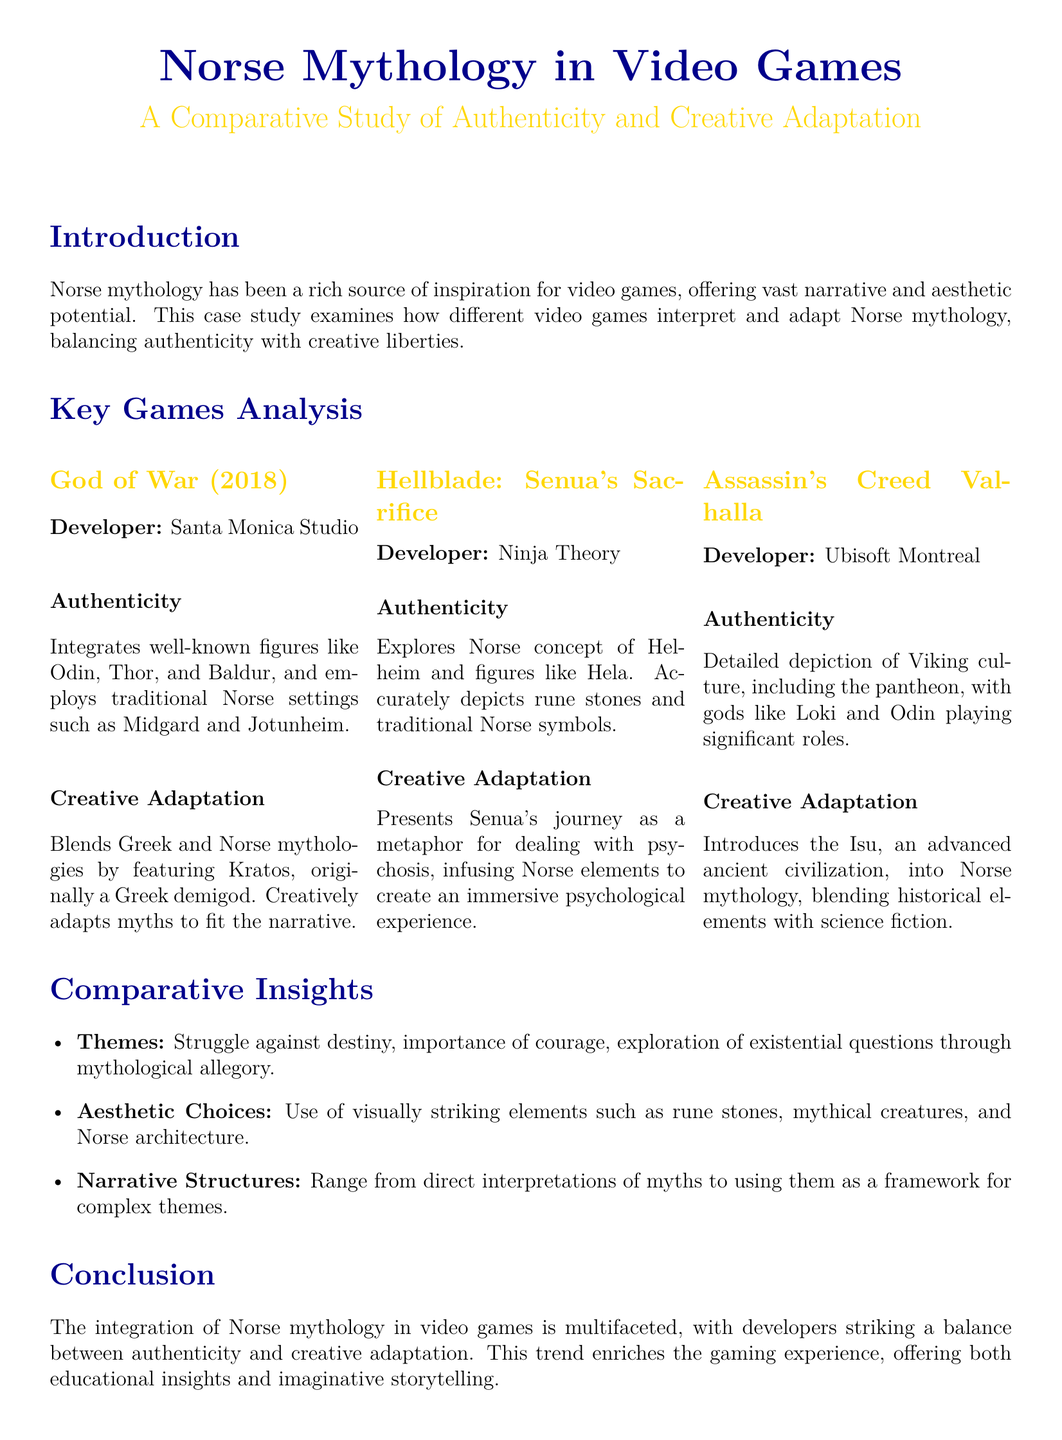What is the title of the case study? The title of the case study is given at the beginning of the document, which outlines its main theme about Norse mythology in video games.
Answer: Norse Mythology in Video Games: A Comparative Study of Authenticity and Creative Adaptation Who developed Hellblade: Senua's Sacrifice? The developer of Hellblade: Senua's Sacrifice is specified under its analysis section in the document.
Answer: Ninja Theory Which two mythologies are blended in God of War (2018)? The document discusses how God of War (2018) creatively blends two specific mythologies in its narrative.
Answer: Greek and Norse What significant figure represents the Norse concept of Helheim in Hellblade: Senua's Sacrifice? The document mentions a specific character that embodies the Norse concept of Helheim.
Answer: Hela What advanced ancient civilization is introduced in Assassin's Creed Valhalla? The document highlights an imaginative element added to Norse mythology within the game.
Answer: Isu Which themes are explored through Norse mythology in these video games? The various games analyzed share thematic elements reflecting deeper societal issues rooted in mythology.
Answer: Struggle against destiny How do developers approach authenticity in these games? The document describes how developers capture elements of Norse mythology while also including creative aspects.
Answer: Detailed depiction of Viking culture What is the conclusion drawn about the integration of Norse mythology in video games? The conclusion summarizes the developers' dual focus on authenticity and creativity as a trend in gaming.
Answer: Multifaceted integration 